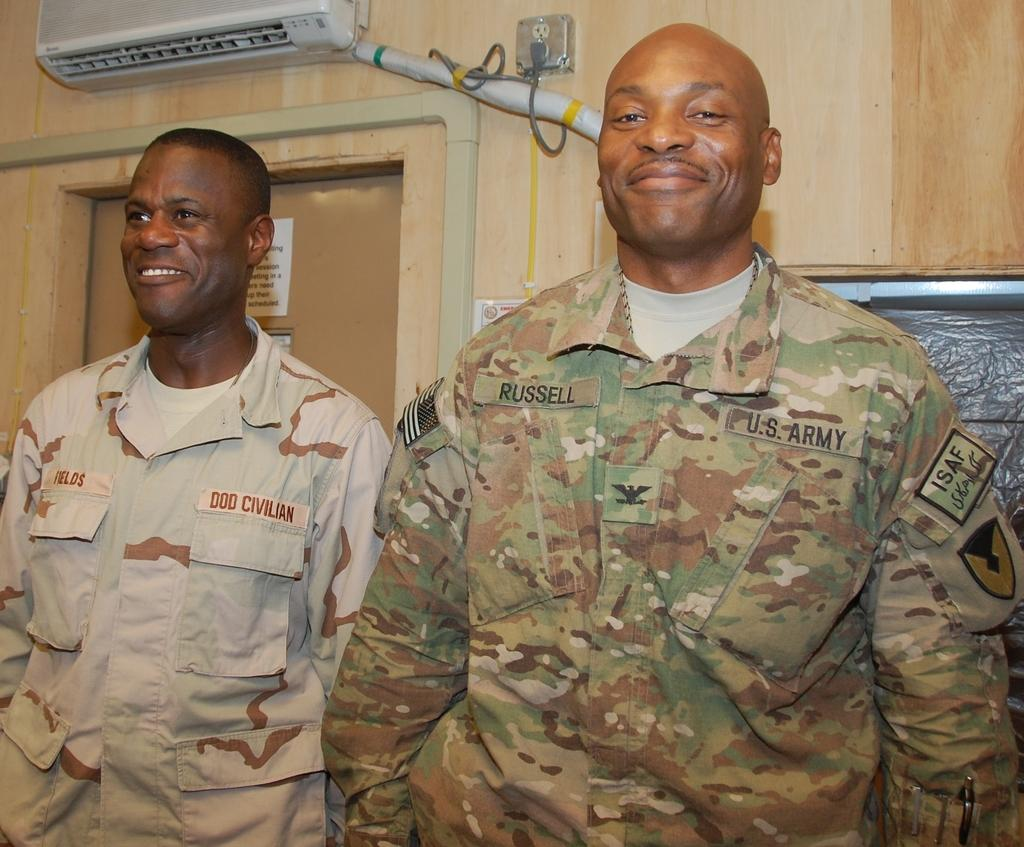What is the man in the image wearing? The man is wearing an army dress. What is the man's facial expression in the image? The man is smiling. Can you describe the other man in the image? There is another man on the left side of the image. What is visible behind the second man? There is a door behind the second man. What type of thread is being used to sew the cabbage in the image? There is no cabbage or thread present in the image. 